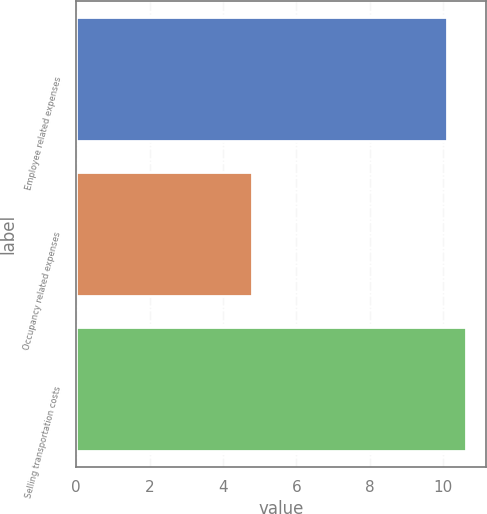<chart> <loc_0><loc_0><loc_500><loc_500><bar_chart><fcel>Employee related expenses<fcel>Occupancy related expenses<fcel>Selling transportation costs<nl><fcel>10.1<fcel>4.8<fcel>10.63<nl></chart> 